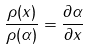Convert formula to latex. <formula><loc_0><loc_0><loc_500><loc_500>\frac { \rho ( x ) } { \rho ( \alpha ) } = \frac { \partial \alpha } { \partial x }</formula> 